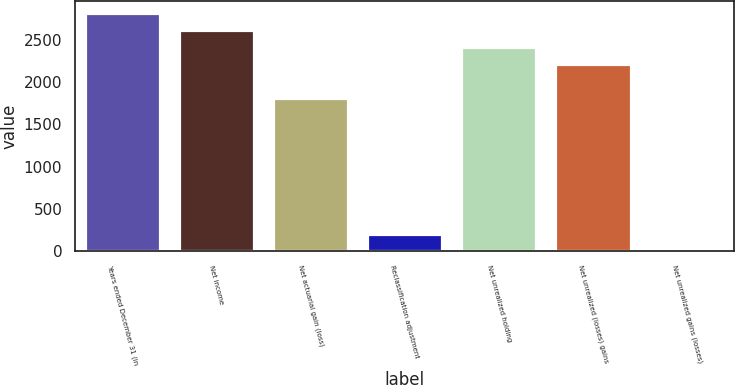Convert chart to OTSL. <chart><loc_0><loc_0><loc_500><loc_500><bar_chart><fcel>Years ended December 31 (in<fcel>Net income<fcel>Net actuarial gain (loss)<fcel>Reclassification adjustment<fcel>Net unrealized holding<fcel>Net unrealized (losses) gains<fcel>Net unrealized gains (losses)<nl><fcel>2817.92<fcel>2616.69<fcel>1811.77<fcel>201.93<fcel>2415.46<fcel>2214.23<fcel>0.7<nl></chart> 